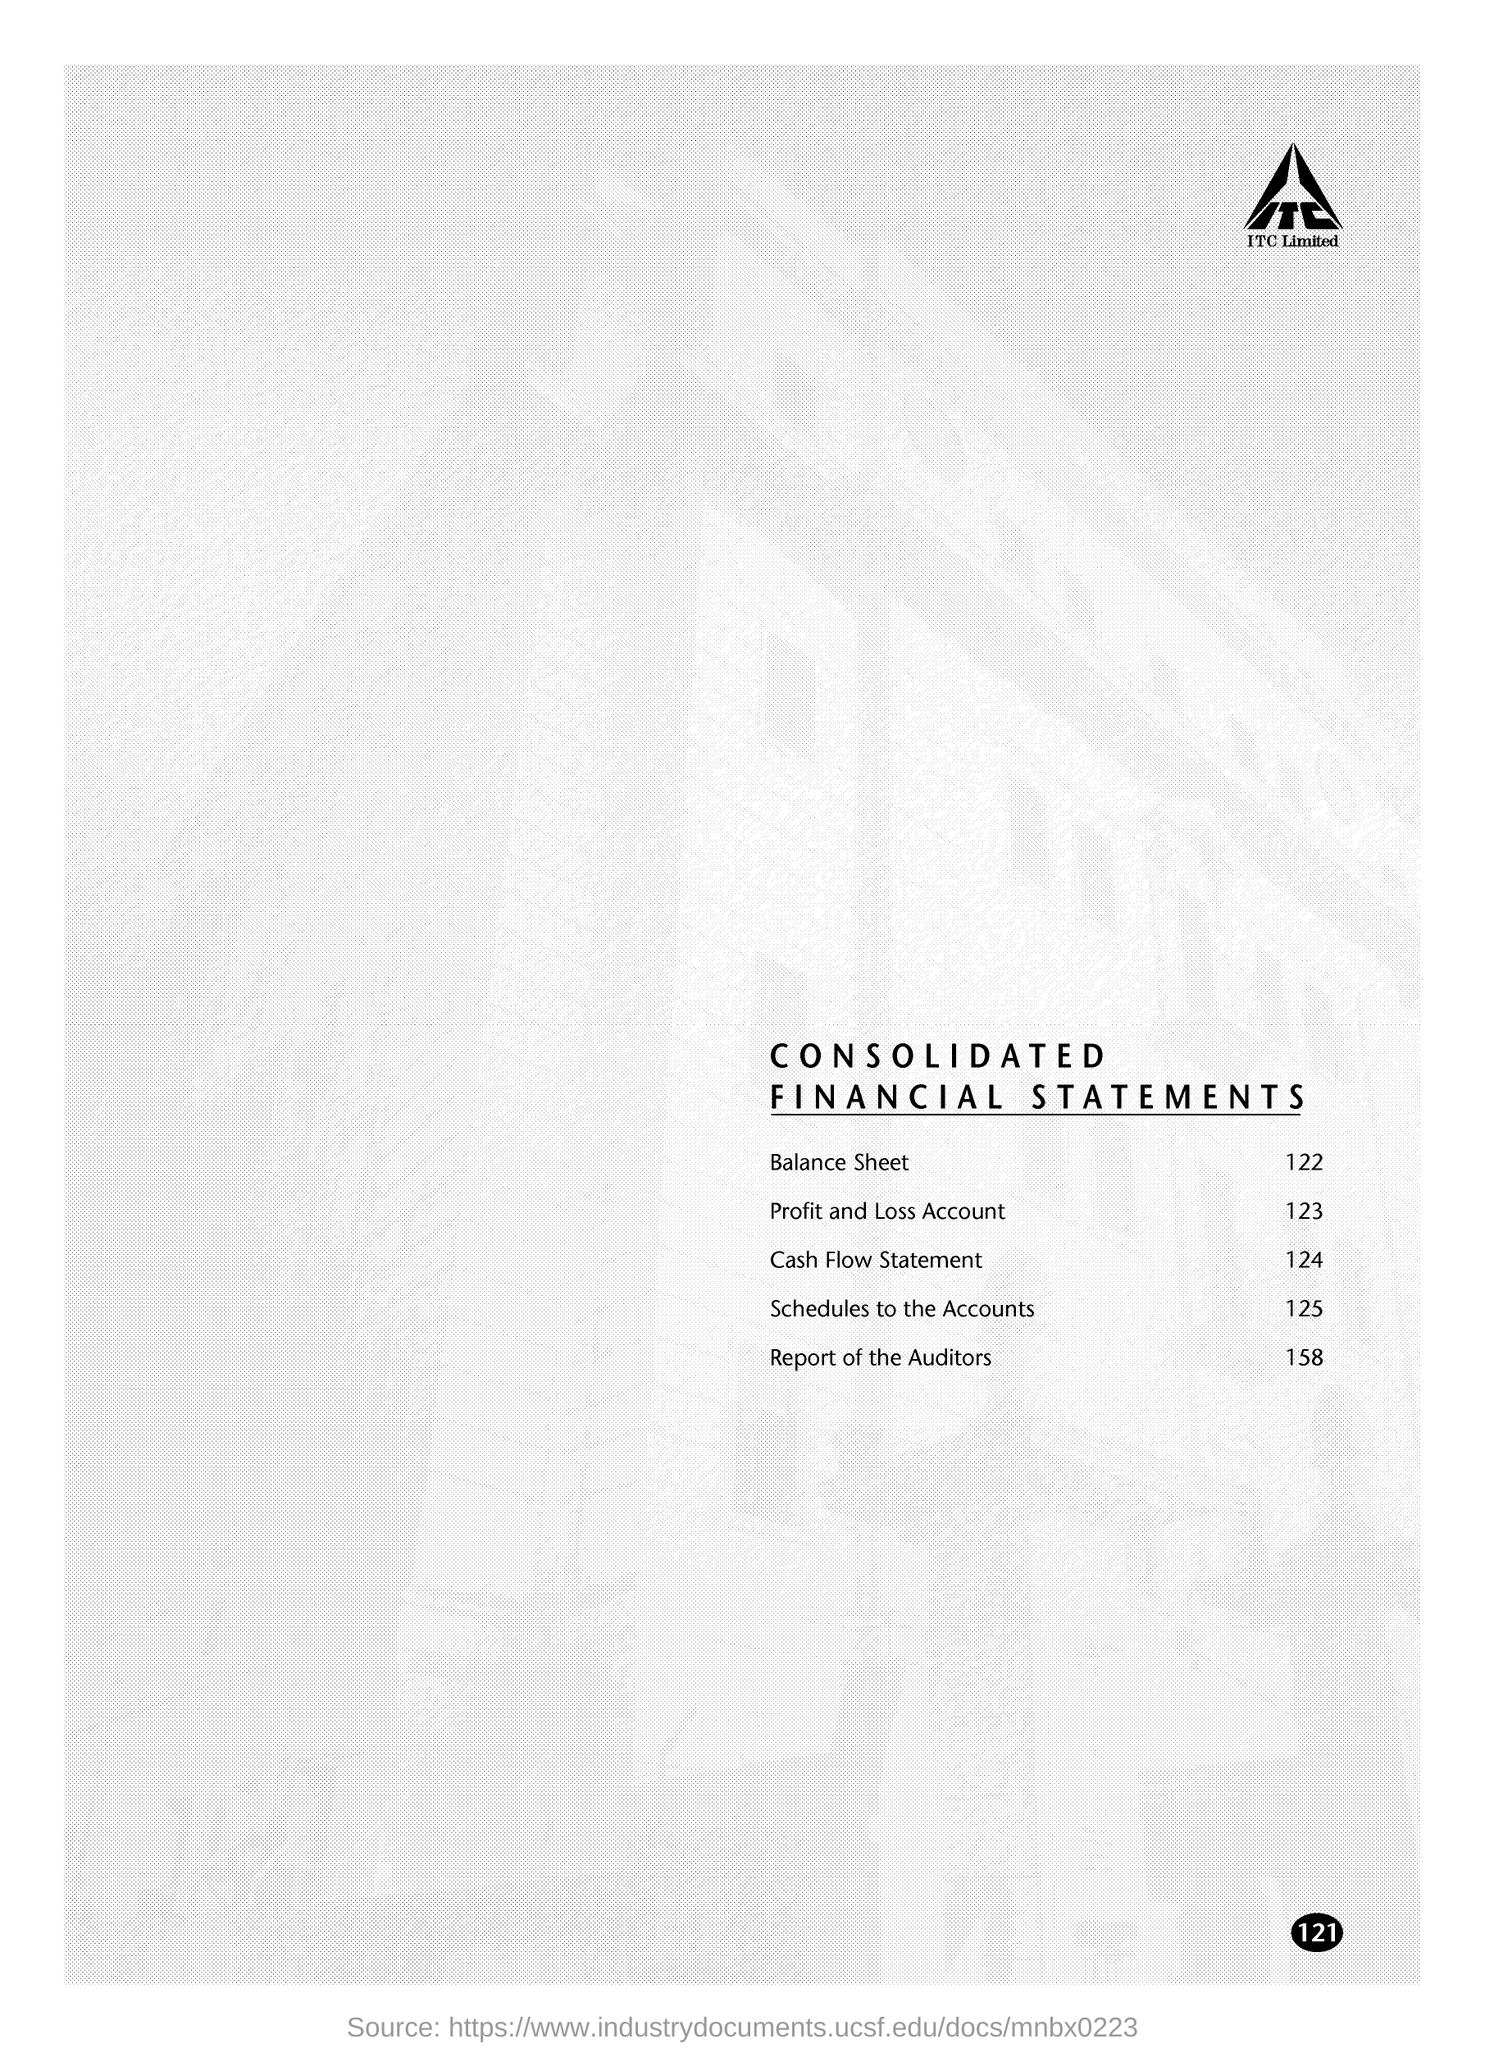Which company's name is at the top of the page?
Give a very brief answer. ITC. What is the document title?
Make the answer very short. CONSOLIDATED FINANCIAL STATEMENTS. On which page is Profit and Loss Account given?
Offer a terse response. 123. What is given on page 158?
Keep it short and to the point. Report of the Auditors. What is the page number on this document?
Your response must be concise. 121. 